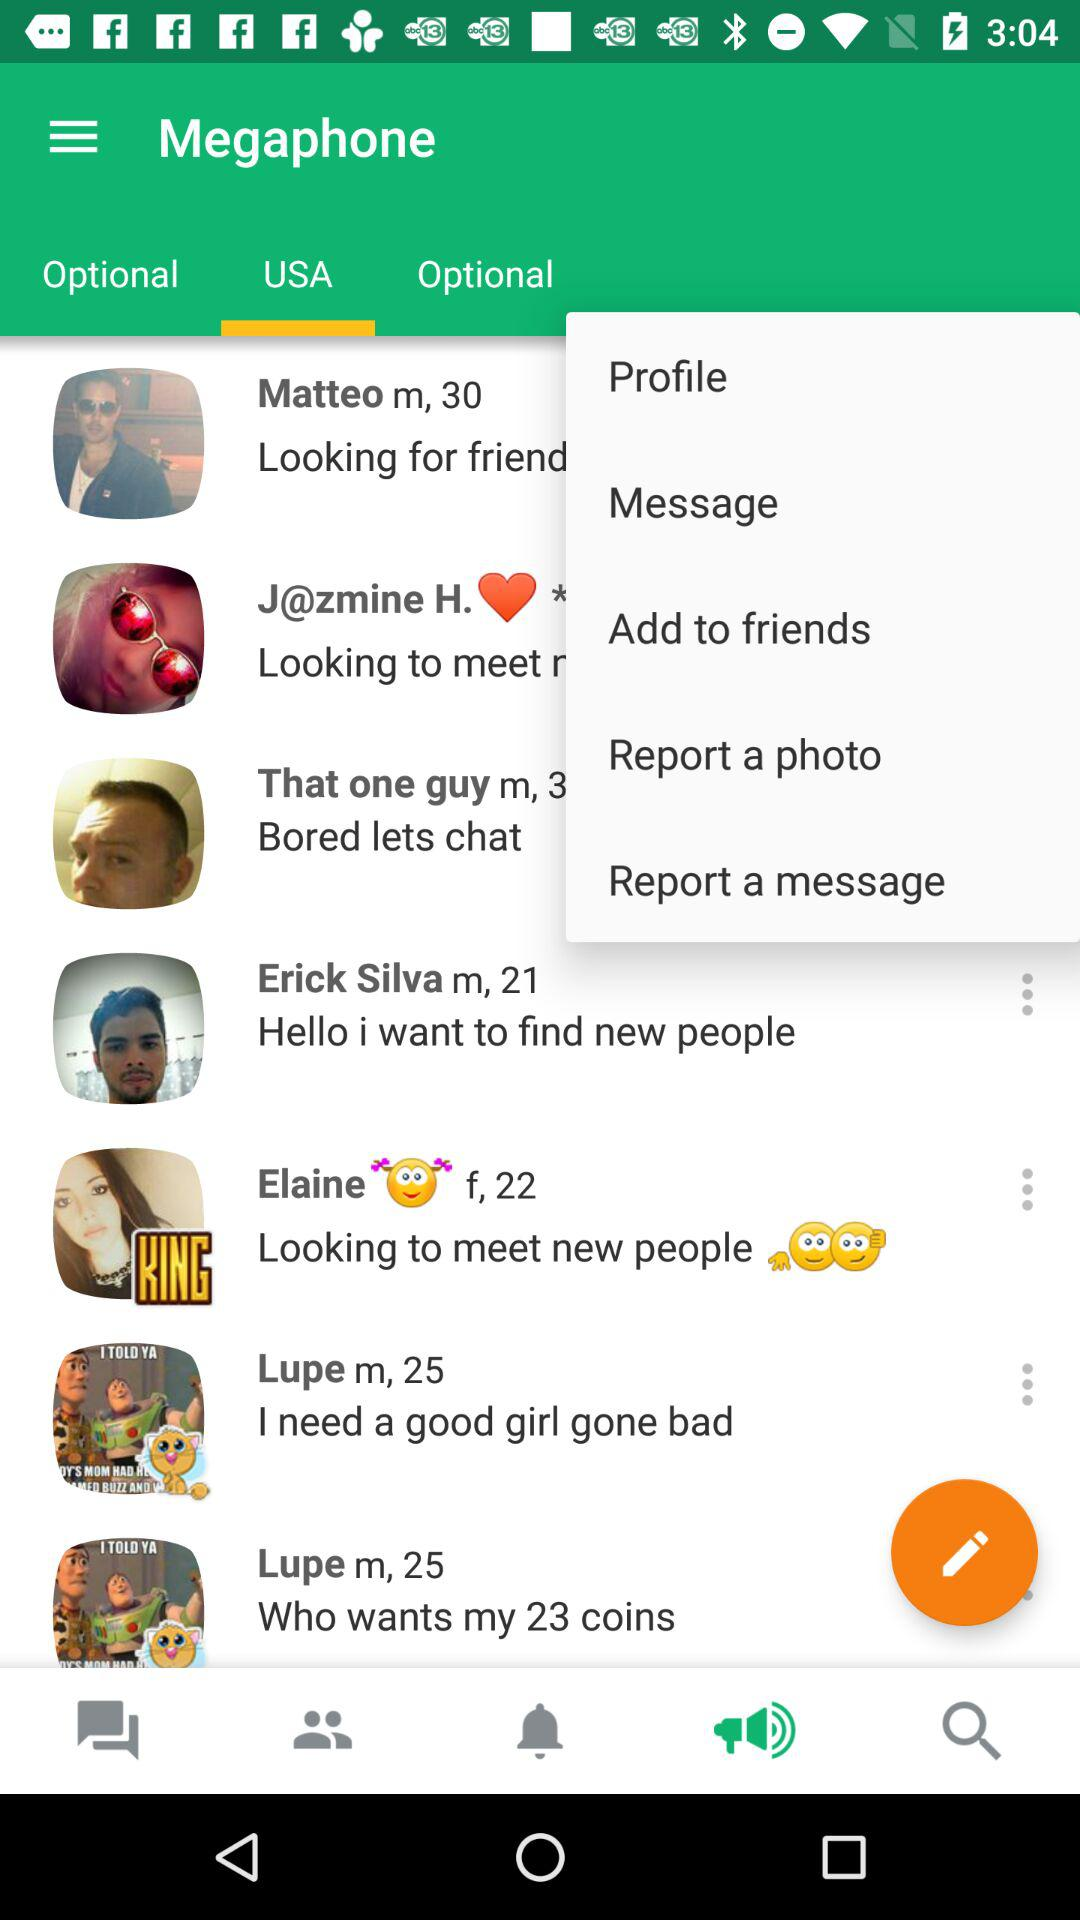What is the application name? The application name is "Megaphone". 